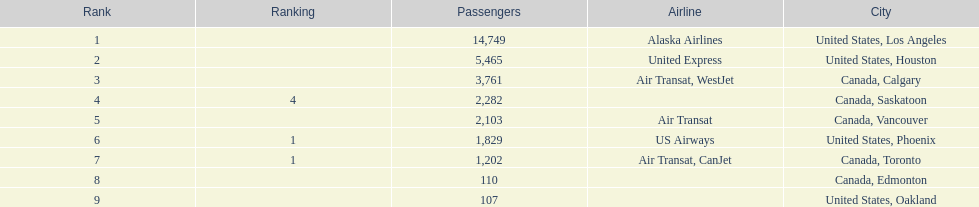The least number of passengers came from which city United States, Oakland. 